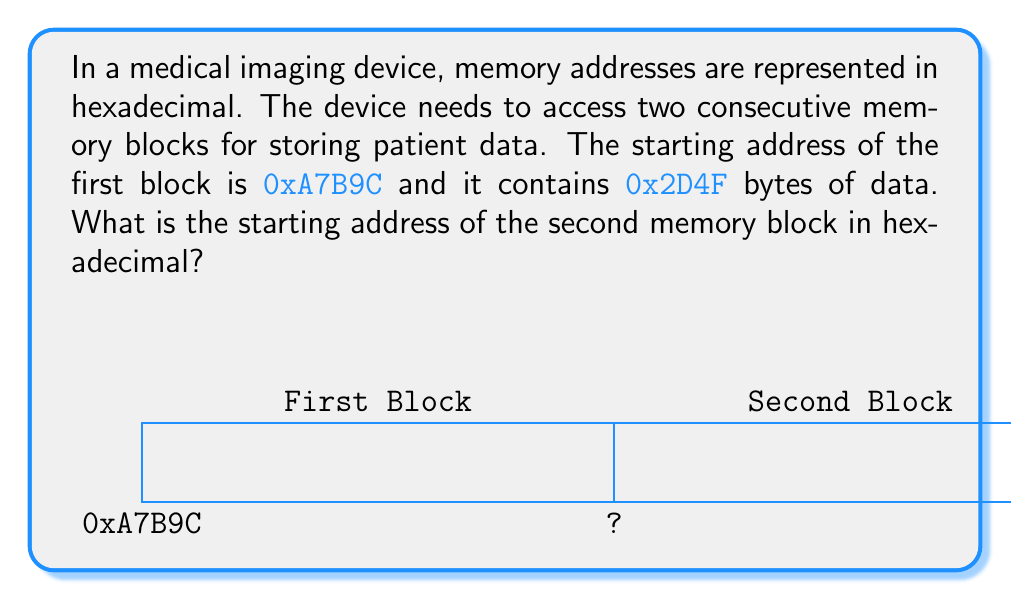Solve this math problem. To solve this problem, we need to follow these steps:

1) The starting address of the first block is 0xA7B9C.
2) The size of the first block is 0x2D4F bytes.
3) To find the starting address of the second block, we need to add the size of the first block to its starting address.

Let's perform the addition in hexadecimal:

$$
\begin{array}{r}
  \text{0xA7B9C} \\
+ \text{0x2D4F} \\
\hline
\end{array}
$$

Starting from the rightmost column:

1) C + F = 1B. We write B and carry 1.
2) 9 + 4 + 1(carried) = E
3) B + D = 18. We write 8 and carry 1.
4) 7 + 2 + 1(carried) = A
5) A remains unchanged as there's nothing to add to it.

Therefore,

$$
\begin{array}{r}
  \text{0xA7B9C} \\
+ \text{0x2D4F} \\
\hline
  \text{0xAA8EB} \\
\end{array}
$$

The starting address of the second memory block is 0xAA8EB.
Answer: 0xAA8EB 